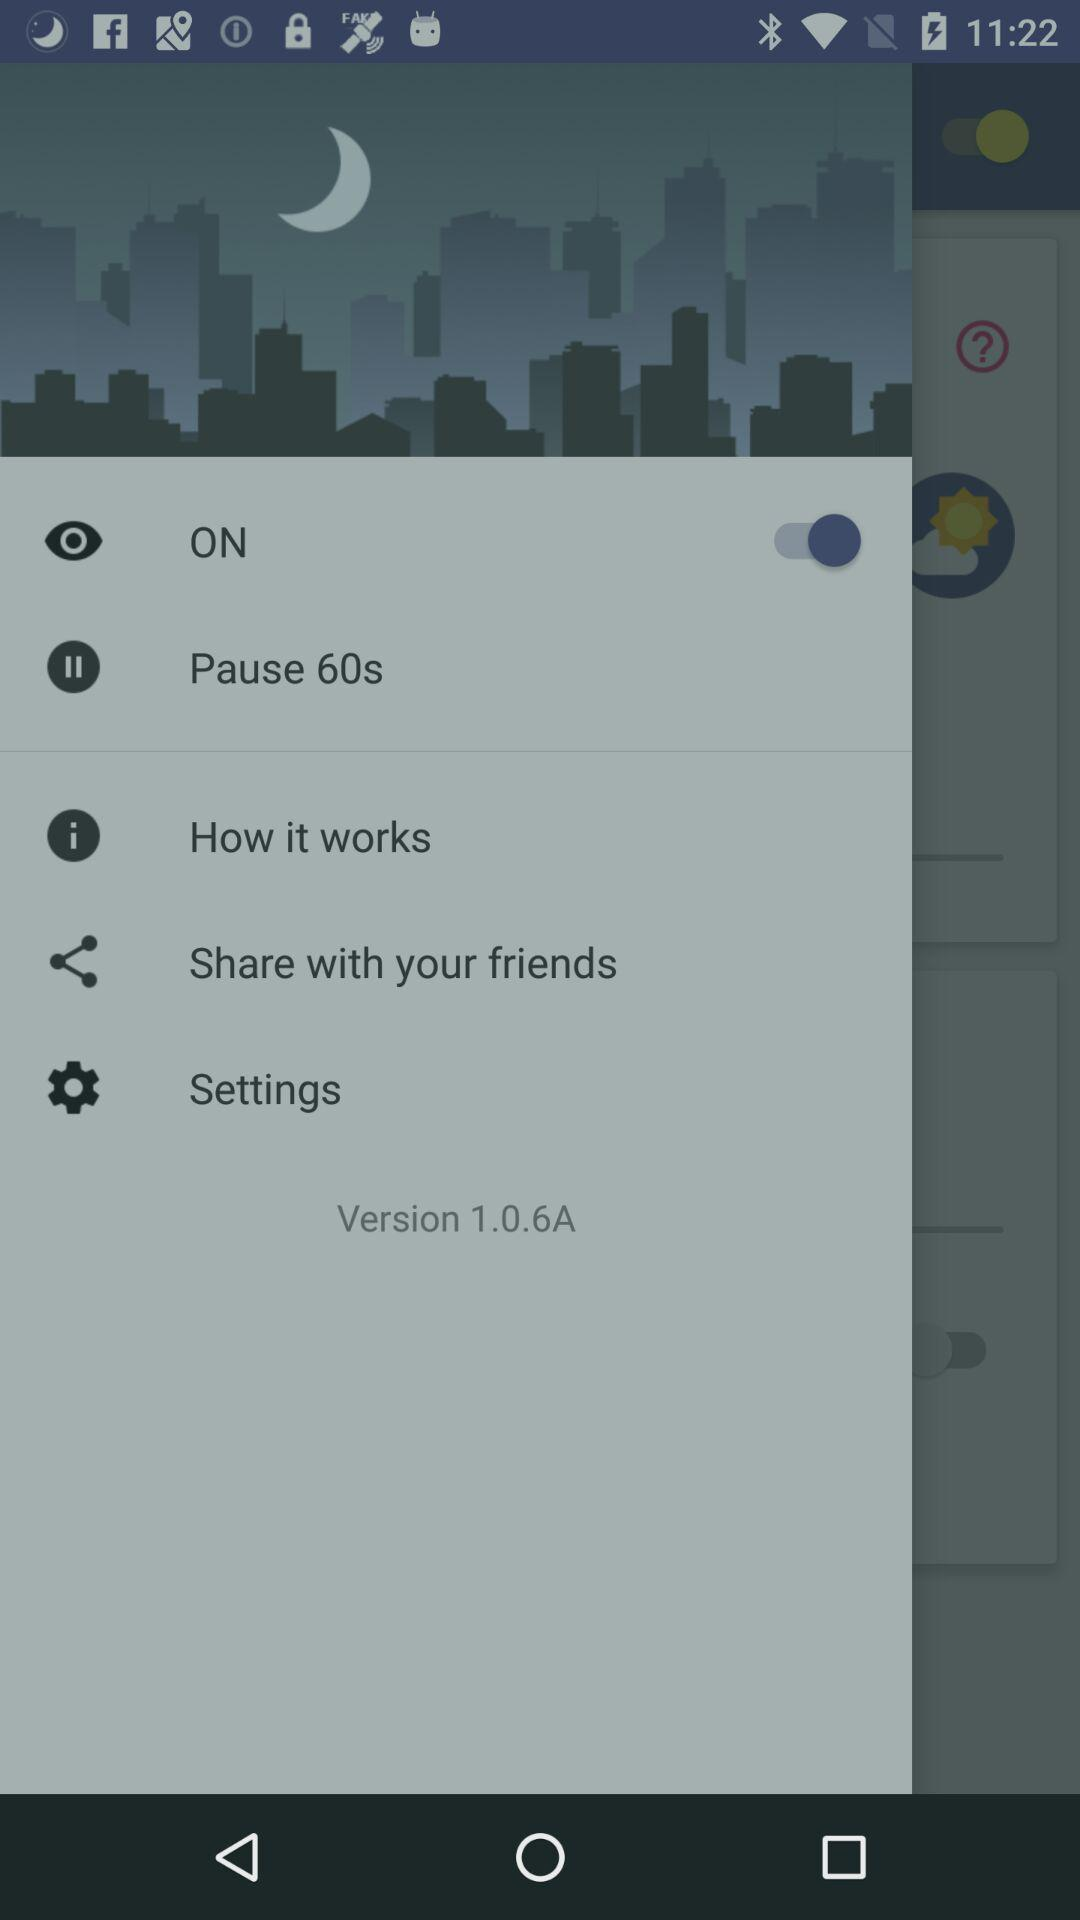What is the status of the "ON"? The status is "on". 